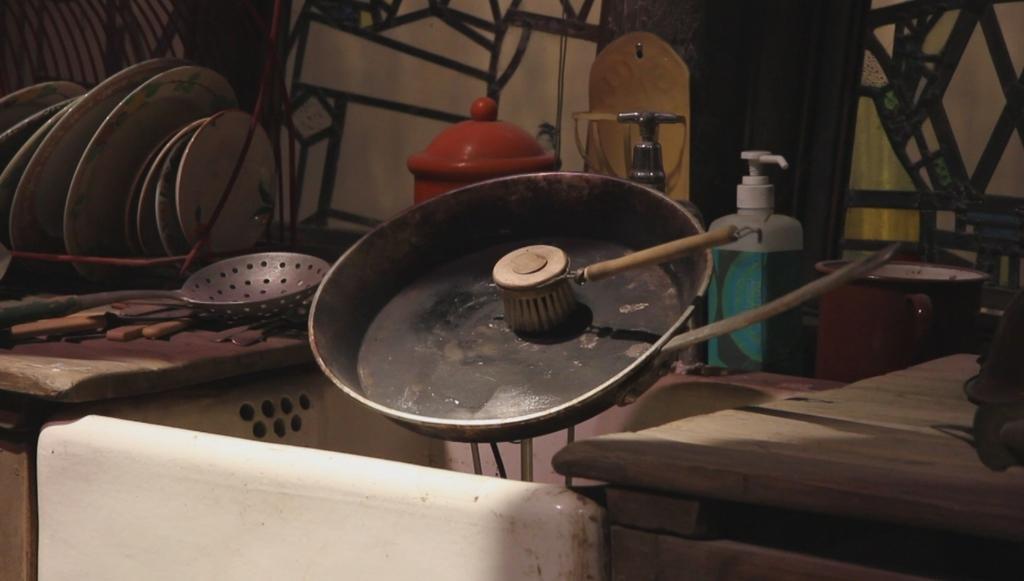In one or two sentences, can you explain what this image depicts? In this picture we can see a pan on the pan there is a wood and left side to the pan we have bottle and a jar and right side to the pan there is a spoon and plates arranged in a queue and we have a wall. Here it is a floor. 